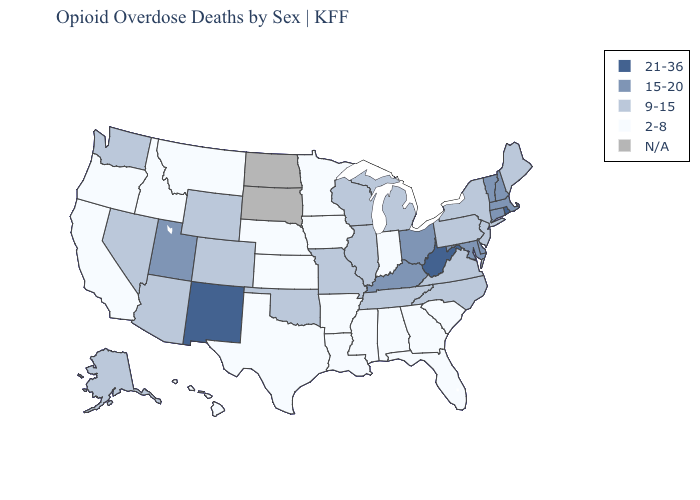Name the states that have a value in the range 21-36?
Concise answer only. New Mexico, Rhode Island, West Virginia. Name the states that have a value in the range N/A?
Write a very short answer. North Dakota, South Dakota. Name the states that have a value in the range 15-20?
Quick response, please. Connecticut, Delaware, Kentucky, Maryland, Massachusetts, New Hampshire, Ohio, Utah, Vermont. What is the highest value in the USA?
Keep it brief. 21-36. Among the states that border Maryland , which have the lowest value?
Concise answer only. Pennsylvania, Virginia. Does Connecticut have the lowest value in the Northeast?
Short answer required. No. What is the lowest value in the USA?
Short answer required. 2-8. Does the map have missing data?
Give a very brief answer. Yes. Name the states that have a value in the range 15-20?
Short answer required. Connecticut, Delaware, Kentucky, Maryland, Massachusetts, New Hampshire, Ohio, Utah, Vermont. Name the states that have a value in the range 2-8?
Concise answer only. Alabama, Arkansas, California, Florida, Georgia, Hawaii, Idaho, Indiana, Iowa, Kansas, Louisiana, Minnesota, Mississippi, Montana, Nebraska, Oregon, South Carolina, Texas. What is the highest value in the USA?
Give a very brief answer. 21-36. Among the states that border Missouri , which have the highest value?
Concise answer only. Kentucky. What is the value of Delaware?
Keep it brief. 15-20. Name the states that have a value in the range 15-20?
Give a very brief answer. Connecticut, Delaware, Kentucky, Maryland, Massachusetts, New Hampshire, Ohio, Utah, Vermont. 